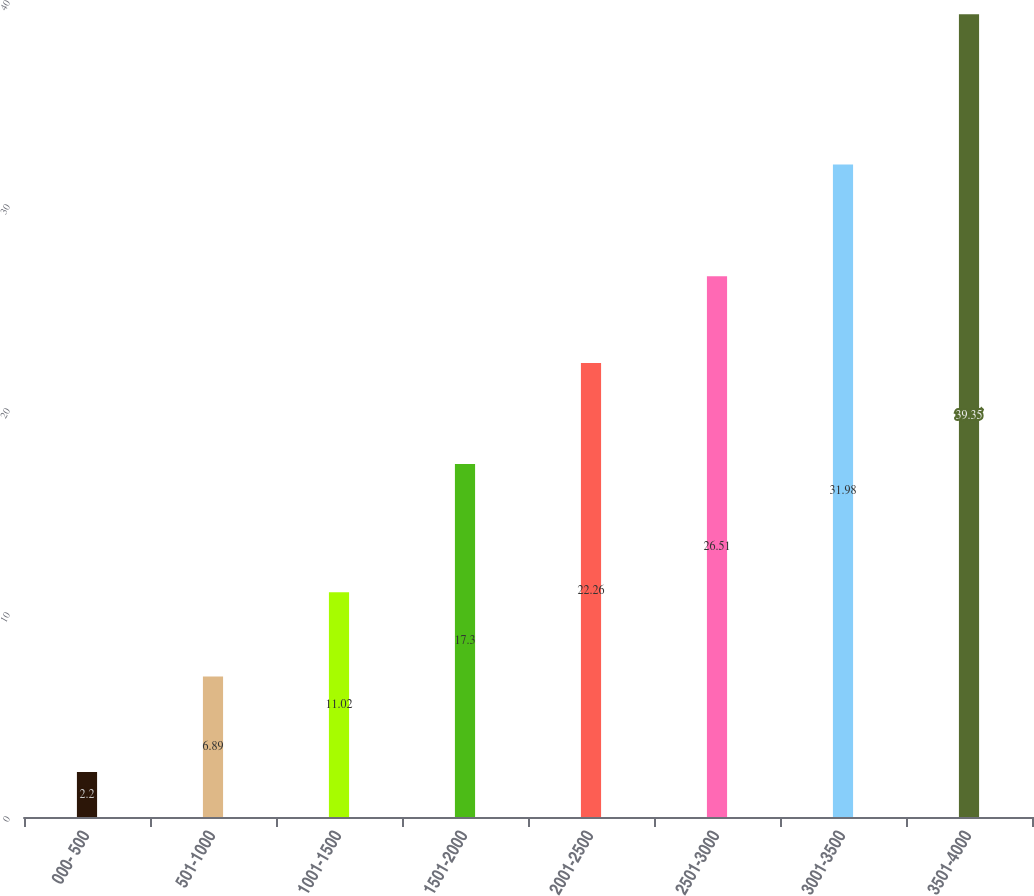Convert chart to OTSL. <chart><loc_0><loc_0><loc_500><loc_500><bar_chart><fcel>000- 500<fcel>501-1000<fcel>1001-1500<fcel>1501-2000<fcel>2001-2500<fcel>2501-3000<fcel>3001-3500<fcel>3501-4000<nl><fcel>2.2<fcel>6.89<fcel>11.02<fcel>17.3<fcel>22.26<fcel>26.51<fcel>31.98<fcel>39.35<nl></chart> 